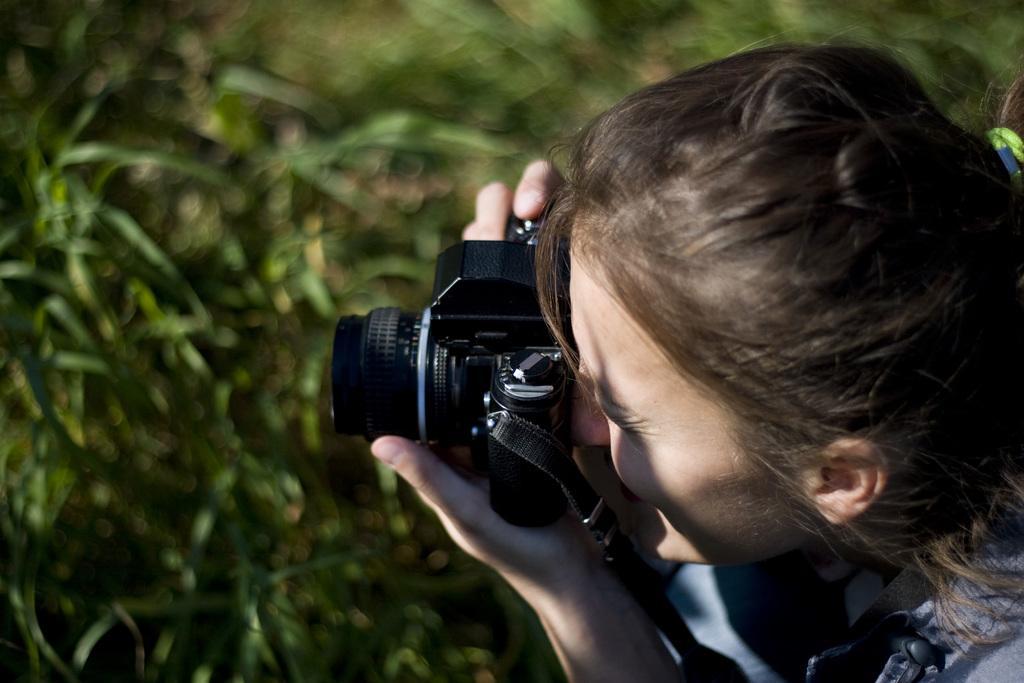In one or two sentences, can you explain what this image depicts? In this picture we can see woman holding camera with her hand and taking picture and in the background we can see trees and it is blurry. 